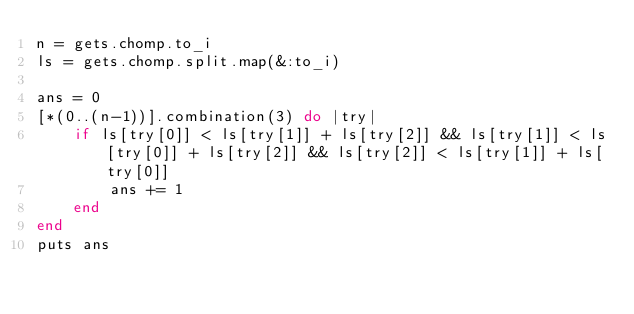<code> <loc_0><loc_0><loc_500><loc_500><_Ruby_>n = gets.chomp.to_i
ls = gets.chomp.split.map(&:to_i)

ans = 0
[*(0..(n-1))].combination(3) do |try|
    if ls[try[0]] < ls[try[1]] + ls[try[2]] && ls[try[1]] < ls[try[0]] + ls[try[2]] && ls[try[2]] < ls[try[1]] + ls[try[0]]
        ans += 1
    end
end
puts ans</code> 